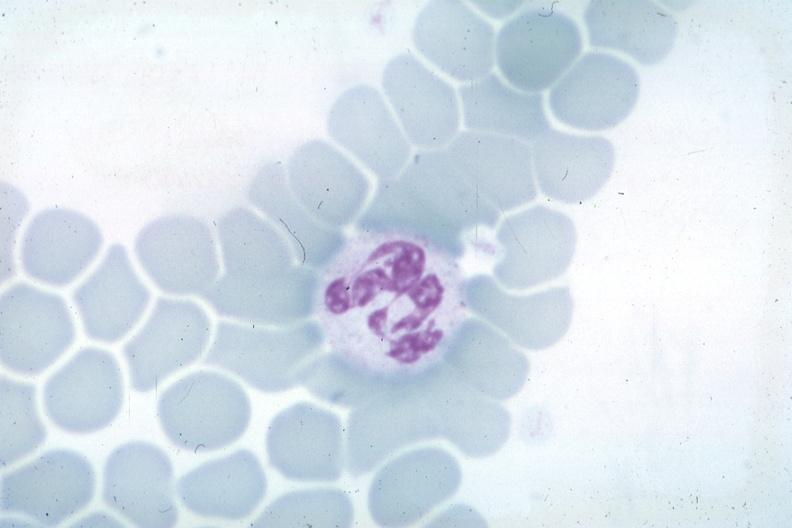what does this image show?
Answer the question using a single word or phrase. Wrights not the best photograph for color 